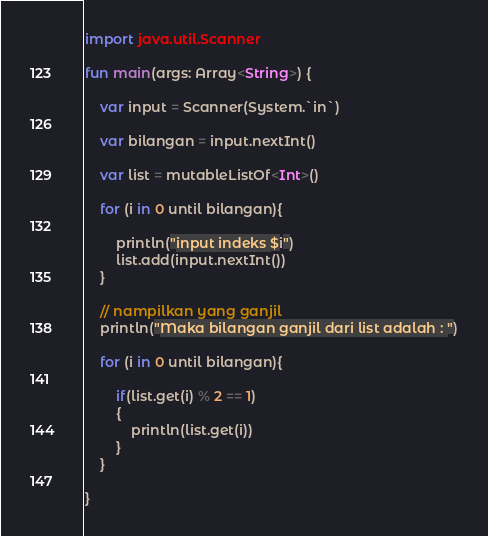Convert code to text. <code><loc_0><loc_0><loc_500><loc_500><_Kotlin_>import java.util.Scanner

fun main(args: Array<String>) {

    var input = Scanner(System.`in`)

    var bilangan = input.nextInt()

    var list = mutableListOf<Int>()

    for (i in 0 until bilangan){

        println("input indeks $i")
        list.add(input.nextInt())
    }

    // nampilkan yang ganjil
    println("Maka bilangan ganjil dari list adalah : ")

    for (i in 0 until bilangan){

        if(list.get(i) % 2 == 1)
        {
            println(list.get(i))
        }
    }

}</code> 